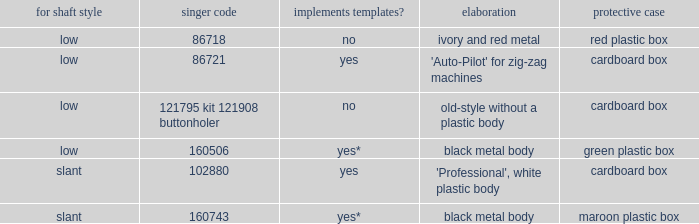What's the storage case of the buttonholer described as ivory and red metal? Red plastic box. 